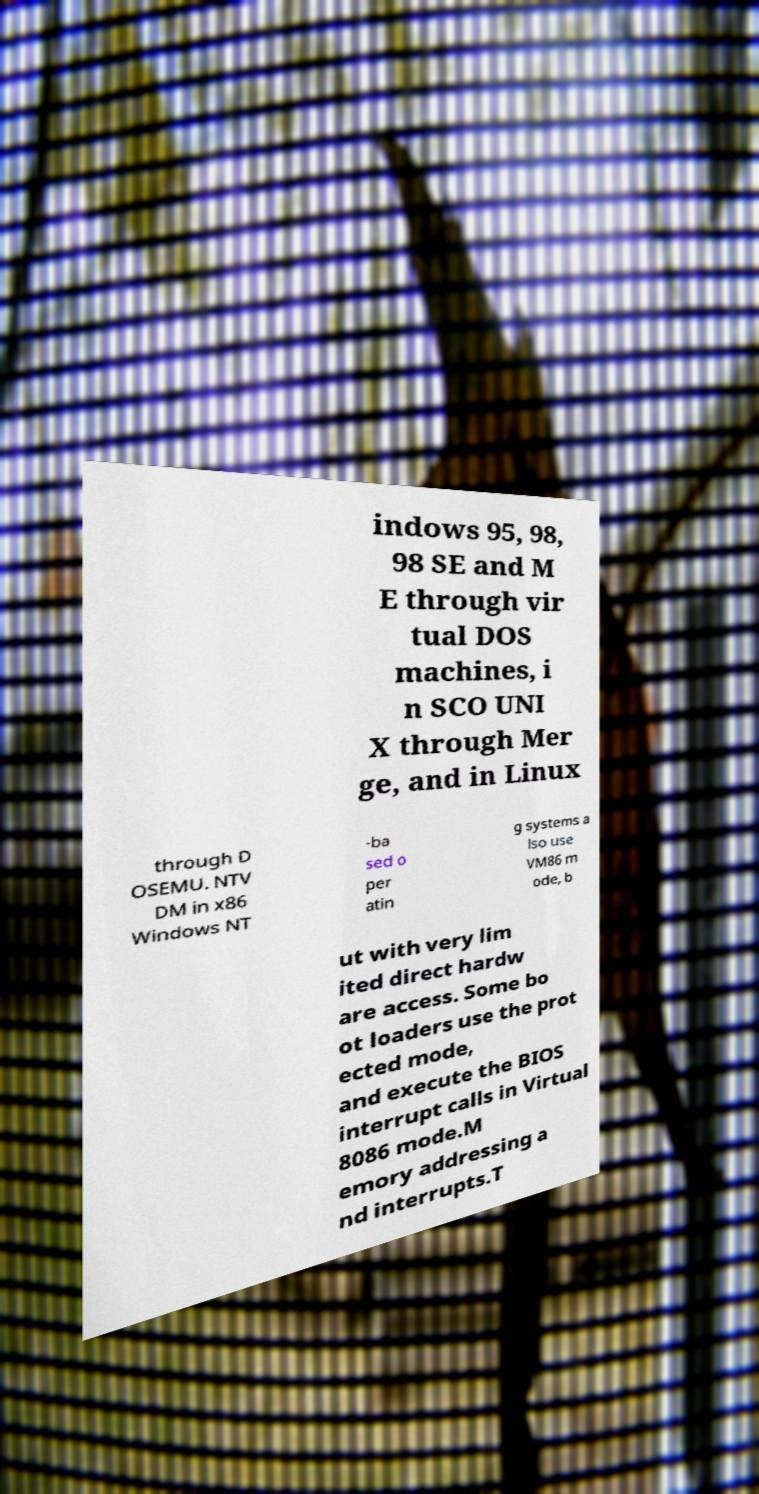Can you accurately transcribe the text from the provided image for me? indows 95, 98, 98 SE and M E through vir tual DOS machines, i n SCO UNI X through Mer ge, and in Linux through D OSEMU. NTV DM in x86 Windows NT -ba sed o per atin g systems a lso use VM86 m ode, b ut with very lim ited direct hardw are access. Some bo ot loaders use the prot ected mode, and execute the BIOS interrupt calls in Virtual 8086 mode.M emory addressing a nd interrupts.T 